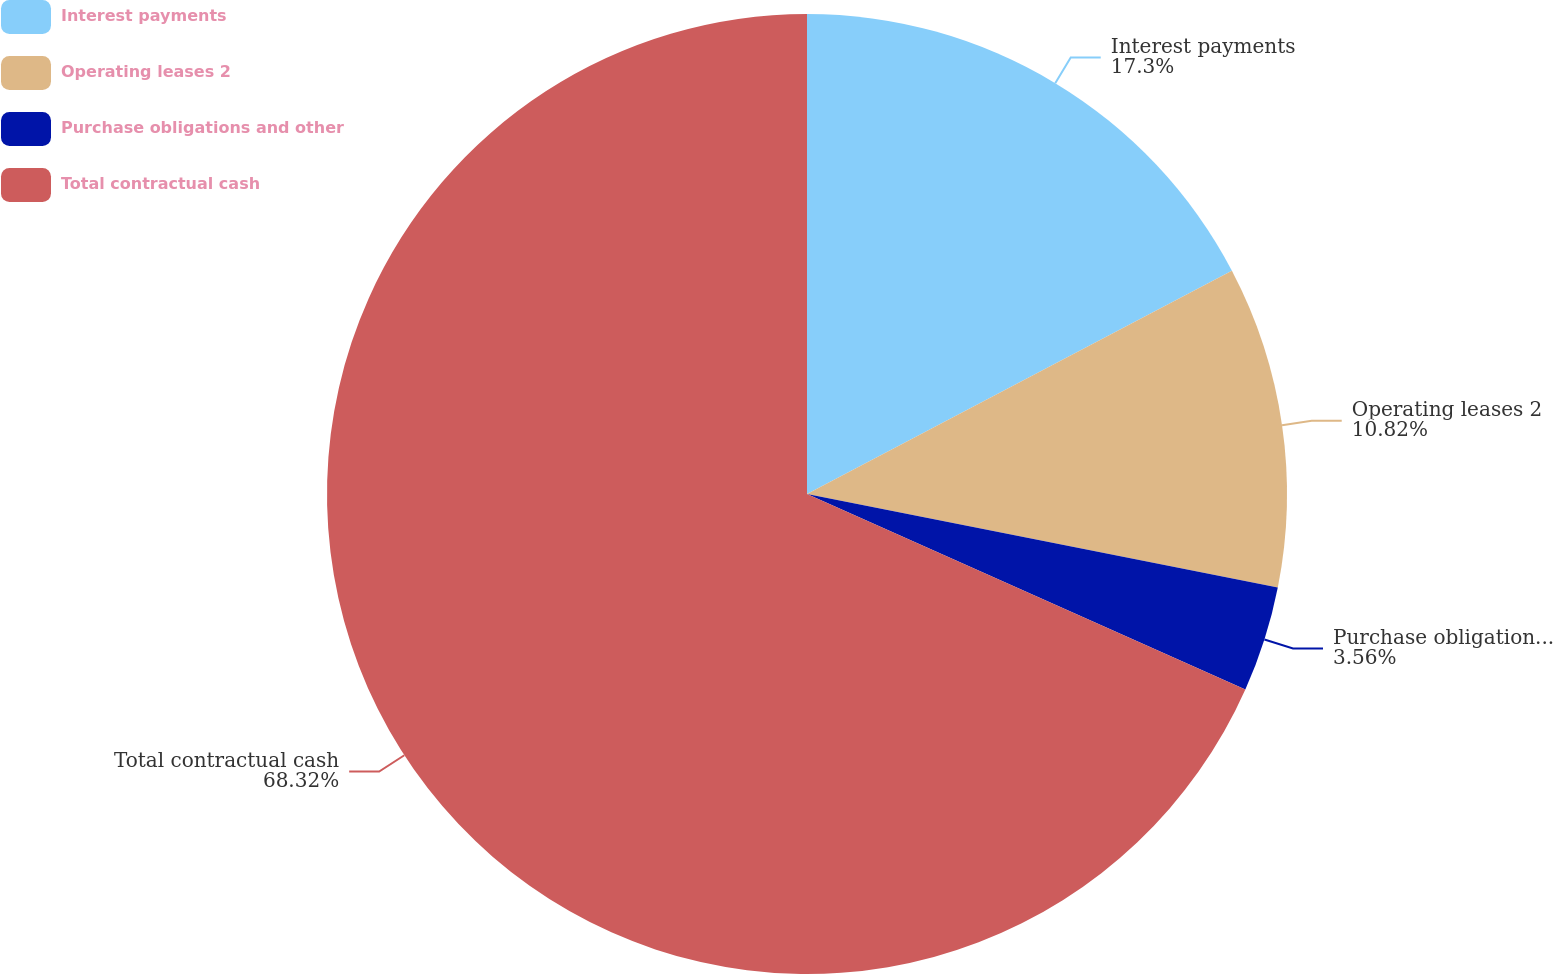<chart> <loc_0><loc_0><loc_500><loc_500><pie_chart><fcel>Interest payments<fcel>Operating leases 2<fcel>Purchase obligations and other<fcel>Total contractual cash<nl><fcel>17.3%<fcel>10.82%<fcel>3.56%<fcel>68.32%<nl></chart> 